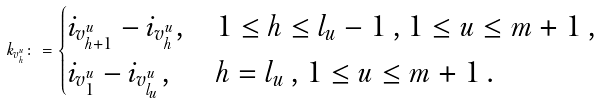<formula> <loc_0><loc_0><loc_500><loc_500>k _ { v ^ { u } _ { h } } \colon = \begin{cases} i _ { v ^ { u } _ { h + 1 } } - i _ { v ^ { u } _ { h } } , & 1 \leq h \leq l _ { u } - 1 \, , 1 \leq u \leq m + 1 \, , \\ i _ { v ^ { u } _ { 1 } } - i _ { v ^ { u } _ { l _ { u } } } , & h = l _ { u } \, , 1 \leq u \leq m + 1 \, . \end{cases}</formula> 